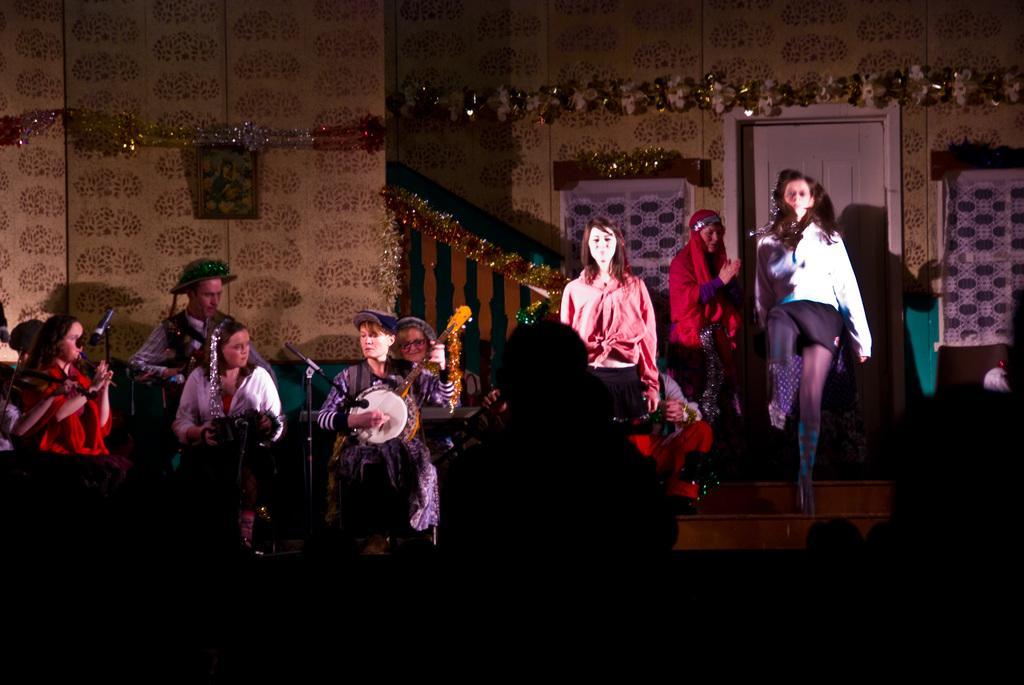Please provide a concise description of this image. Picture and decorative ribbons are on the wall. In-front of this door and windows these people are standing. These people are playing musical instruments in-front of mic 